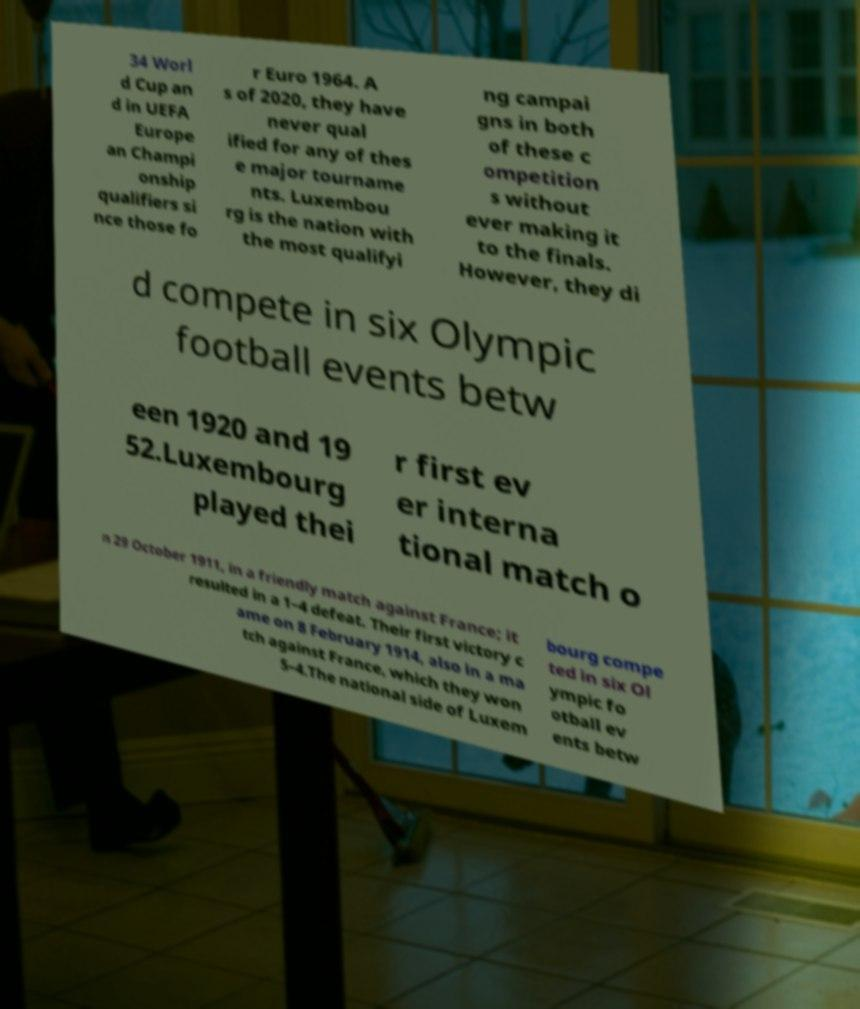Please read and relay the text visible in this image. What does it say? 34 Worl d Cup an d in UEFA Europe an Champi onship qualifiers si nce those fo r Euro 1964. A s of 2020, they have never qual ified for any of thes e major tourname nts. Luxembou rg is the nation with the most qualifyi ng campai gns in both of these c ompetition s without ever making it to the finals. However, they di d compete in six Olympic football events betw een 1920 and 19 52.Luxembourg played thei r first ev er interna tional match o n 29 October 1911, in a friendly match against France; it resulted in a 1–4 defeat. Their first victory c ame on 8 February 1914, also in a ma tch against France, which they won 5–4.The national side of Luxem bourg compe ted in six Ol ympic fo otball ev ents betw 